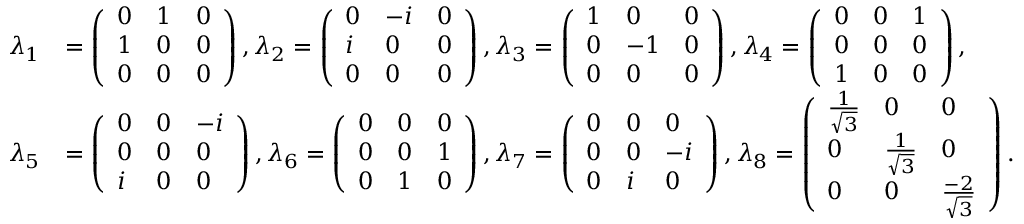Convert formula to latex. <formula><loc_0><loc_0><loc_500><loc_500>\begin{array} { r l } { \lambda _ { 1 } } & { = \left ( \begin{array} { l l l } { 0 } & { 1 } & { 0 } \\ { 1 } & { 0 } & { 0 } \\ { 0 } & { 0 } & { 0 } \end{array} \right ) , \lambda _ { 2 } = \left ( \begin{array} { l l l } { 0 } & { - i } & { 0 } \\ { i } & { 0 } & { 0 } \\ { 0 } & { 0 } & { 0 } \end{array} \right ) , \lambda _ { 3 } = \left ( \begin{array} { l l l } { 1 } & { 0 } & { 0 } \\ { 0 } & { - 1 } & { 0 } \\ { 0 } & { 0 } & { 0 } \end{array} \right ) , \lambda _ { 4 } = \left ( \begin{array} { l l l } { 0 } & { 0 } & { 1 } \\ { 0 } & { 0 } & { 0 } \\ { 1 } & { 0 } & { 0 } \end{array} \right ) , } \\ { \lambda _ { 5 } } & { = \left ( \begin{array} { l l l } { 0 } & { 0 } & { - i } \\ { 0 } & { 0 } & { 0 } \\ { i } & { 0 } & { 0 } \end{array} \right ) , \lambda _ { 6 } = \left ( \begin{array} { l l l } { 0 } & { 0 } & { 0 } \\ { 0 } & { 0 } & { 1 } \\ { 0 } & { 1 } & { 0 } \end{array} \right ) , \lambda _ { 7 } = \left ( \begin{array} { l l l } { 0 } & { 0 } & { 0 } \\ { 0 } & { 0 } & { - i } \\ { 0 } & { i } & { 0 } \end{array} \right ) , \lambda _ { 8 } = \left ( \begin{array} { l l l } { \frac { 1 } { \sqrt { 3 } } } & { 0 } & { 0 } \\ { 0 } & { \frac { 1 } { \sqrt { 3 } } } & { 0 } \\ { 0 } & { 0 } & { \frac { - 2 } { \sqrt { 3 } } } \end{array} \right ) . } \end{array}</formula> 